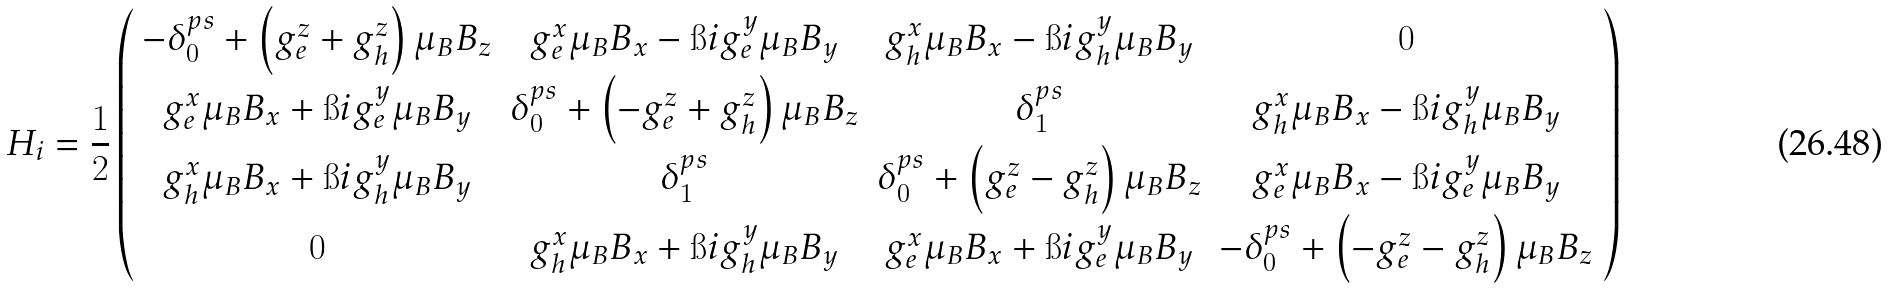Convert formula to latex. <formula><loc_0><loc_0><loc_500><loc_500>H _ { i } = \frac { 1 } { 2 } \left ( \begin{array} { c c c c } - \delta _ { 0 } ^ { p s } + \left ( g _ { e } ^ { z } + g _ { h } ^ { z } \right ) \mu _ { B } B _ { z } & g _ { e } ^ { x } \mu _ { B } B _ { x } - \i i g _ { e } ^ { y } \mu _ { B } B _ { y } & g _ { h } ^ { x } \mu _ { B } B _ { x } - \i i g _ { h } ^ { y } \mu _ { B } B _ { y } & 0 \\ g _ { e } ^ { x } \mu _ { B } B _ { x } + \i i g _ { e } ^ { y } \mu _ { B } B _ { y } & \delta _ { 0 } ^ { p s } + \left ( - g _ { e } ^ { z } + g _ { h } ^ { z } \right ) \mu _ { B } B _ { z } & \delta _ { 1 } ^ { p s } & g _ { h } ^ { x } \mu _ { B } B _ { x } - \i i g _ { h } ^ { y } \mu _ { B } B _ { y } \\ g _ { h } ^ { x } \mu _ { B } B _ { x } + \i i g _ { h } ^ { y } \mu _ { B } B _ { y } & \delta _ { 1 } ^ { p s } & \delta _ { 0 } ^ { p s } + \left ( g _ { e } ^ { z } - g _ { h } ^ { z } \right ) \mu _ { B } B _ { z } & g _ { e } ^ { x } \mu _ { B } B _ { x } - \i i g _ { e } ^ { y } \mu _ { B } B _ { y } \\ 0 & g _ { h } ^ { x } \mu _ { B } B _ { x } + \i i g _ { h } ^ { y } \mu _ { B } B _ { y } & g _ { e } ^ { x } \mu _ { B } B _ { x } + \i i g _ { e } ^ { y } \mu _ { B } B _ { y } & - \delta _ { 0 } ^ { p s } + \left ( - g _ { e } ^ { z } - g _ { h } ^ { z } \right ) \mu _ { B } B _ { z } \\ \end{array} \right )</formula> 